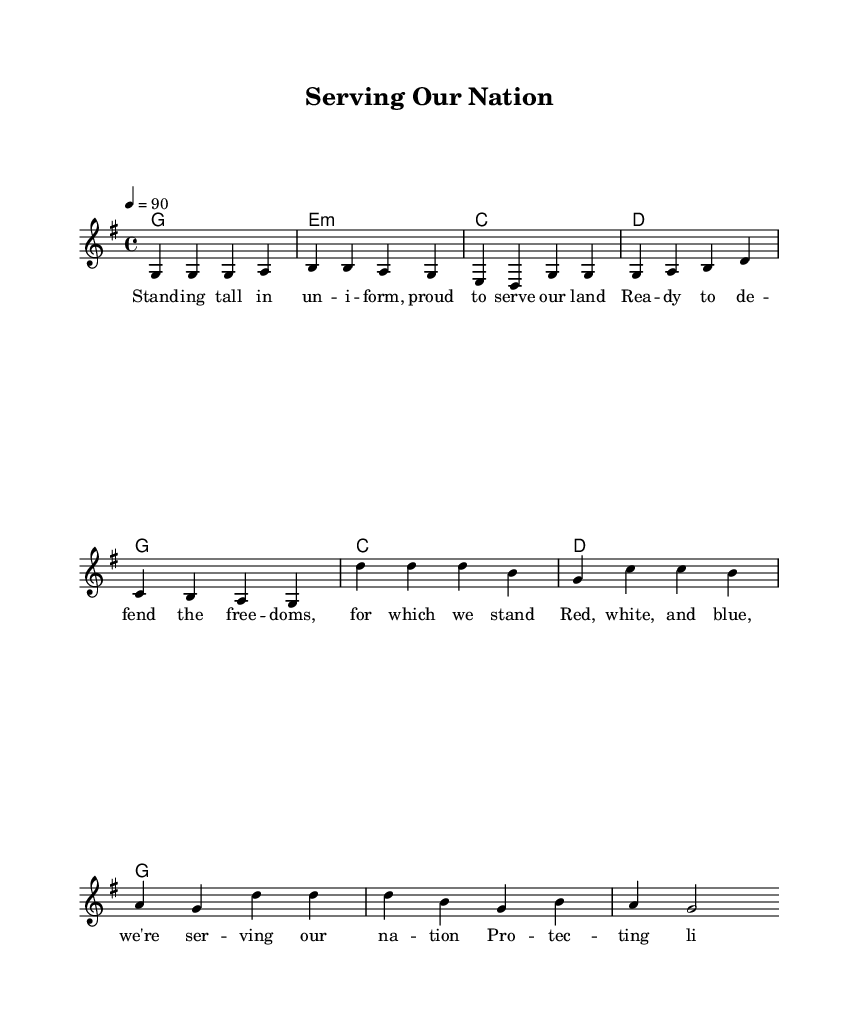What is the key signature of this music? The key signature is G major, which has one sharp (F#). You can determine this by looking at the key signature indication at the beginning of the score, which shows the F# at the top of the staff lines.
Answer: G major What is the time signature of this music? The time signature is 4/4. This can be identified by the notation at the beginning of the score, indicating four beats per measure, with a quarter note receiving one beat.
Answer: 4/4 What is the tempo marking for this piece? The tempo marking is 90 beats per minute. This is indicated in the score with the 'tempo 4 = 90' notation, which specifies the speed of the music.
Answer: 90 How many measures are in the verse section? There are four measures in the verse section. This can be determined by counting the sets of bars within the verse notation.
Answer: 4 Which chord follows the D major chord in the chord progression? The next chord after D major is G major. This relationship is established by looking at the chord progression in the score, where the D chord is followed by G in the sequence.
Answer: G What theme is primarily expressed in the lyrics? The theme expressed in the lyrics is patriotism and service. The words describe pride in serving the nation and a dedication to defending freedom, reflecting patriotic values central to military service.
Answer: Patriotism and service What genre does this song belong to? This song belongs to the Rhythm and Blues genre. You can identify this by the music's style, lyrical content celebrating military service, and the typical rhythms and structures associated with R&B.
Answer: Rhythm and Blues 